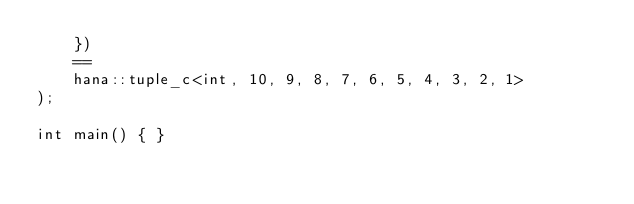<code> <loc_0><loc_0><loc_500><loc_500><_C++_>    })
    ==
    hana::tuple_c<int, 10, 9, 8, 7, 6, 5, 4, 3, 2, 1>
);

int main() { }
</code> 